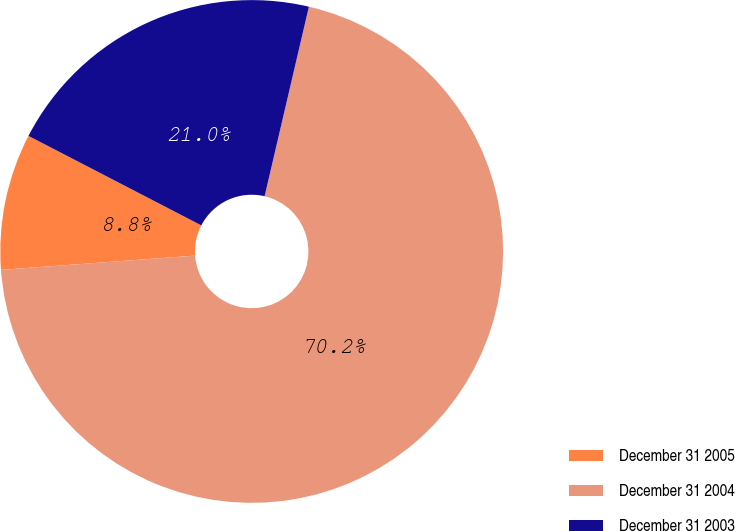Convert chart to OTSL. <chart><loc_0><loc_0><loc_500><loc_500><pie_chart><fcel>December 31 2005<fcel>December 31 2004<fcel>December 31 2003<nl><fcel>8.77%<fcel>70.18%<fcel>21.05%<nl></chart> 